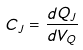Convert formula to latex. <formula><loc_0><loc_0><loc_500><loc_500>C _ { J } = \frac { d Q _ { J } } { d V _ { Q } }</formula> 